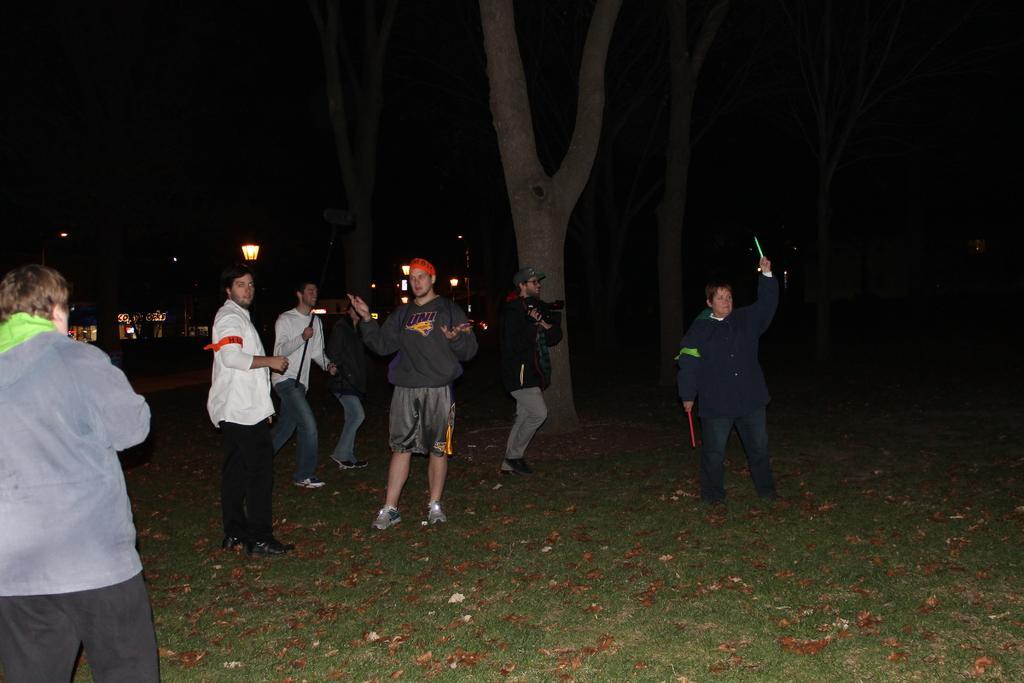Please provide a concise description of this image. In the foreground of the picture there are dry leaves and grass. On the left we can see a person. In the middle there are people and tree. In the background we can see street lights, mostly it is dark and there are trees also. 